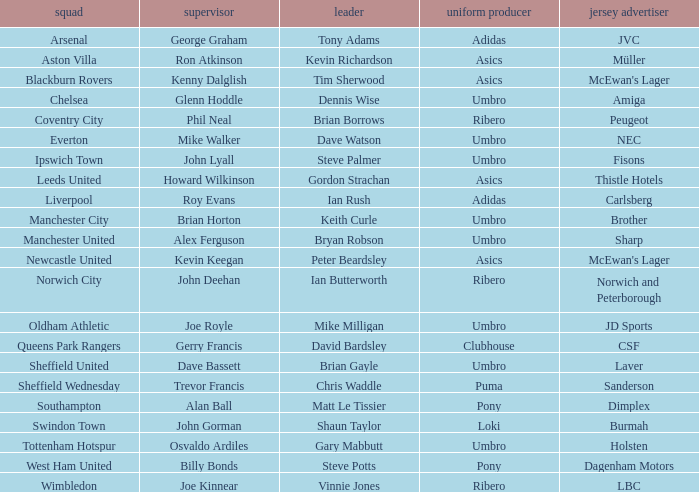Which team has george graham as the manager? Arsenal. 